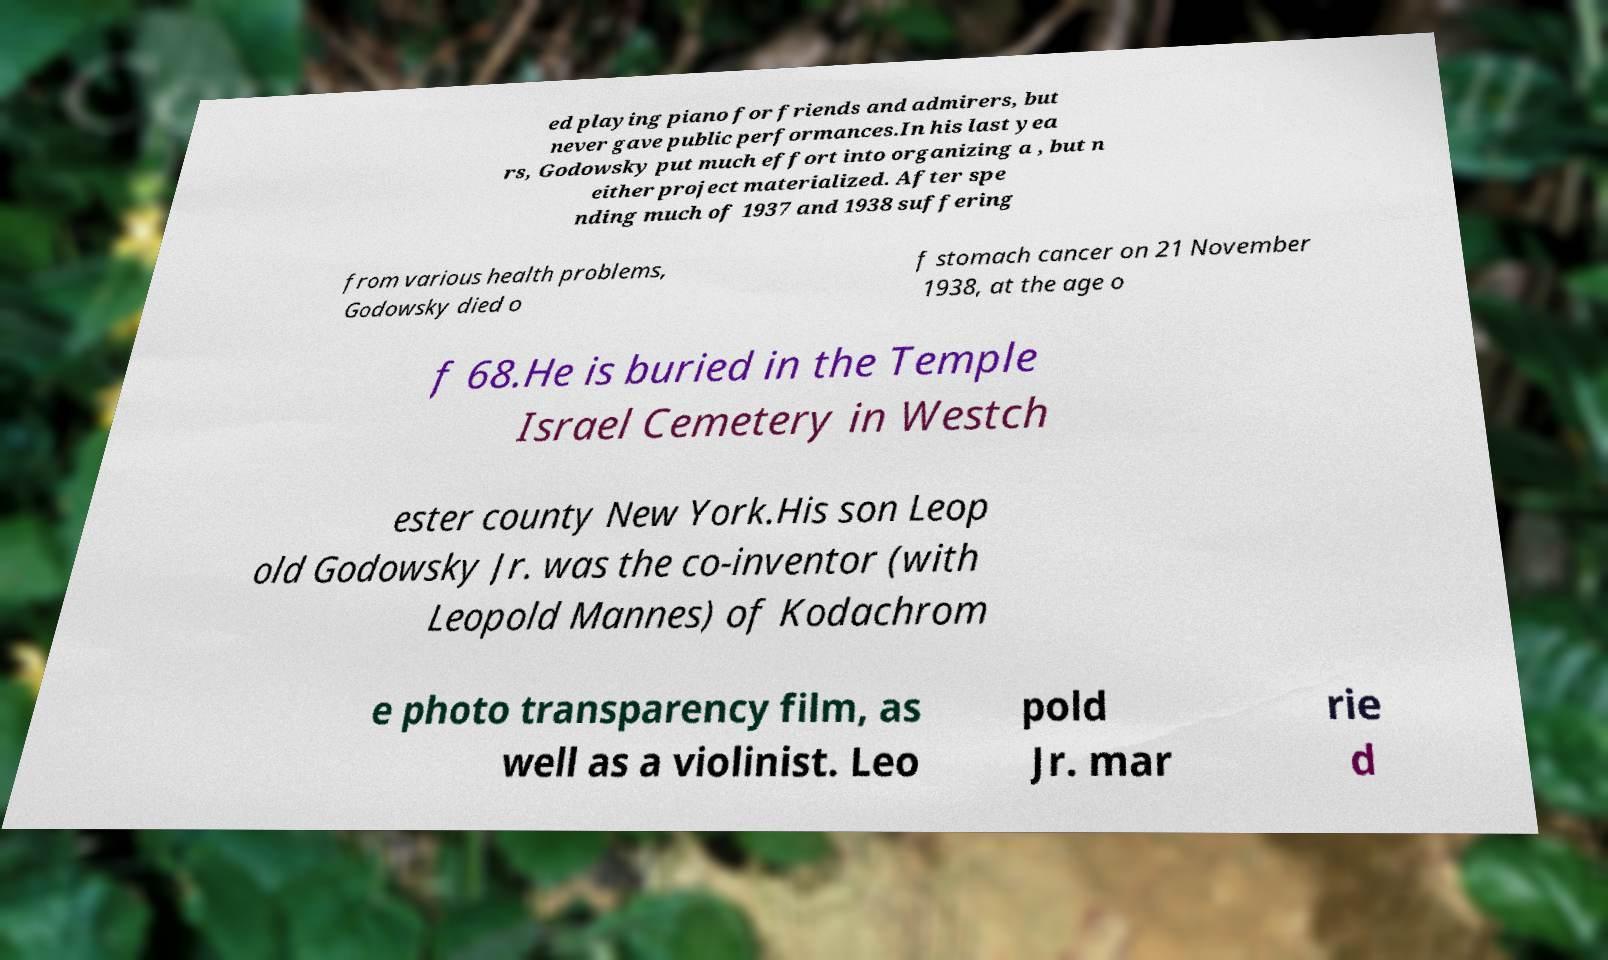I need the written content from this picture converted into text. Can you do that? ed playing piano for friends and admirers, but never gave public performances.In his last yea rs, Godowsky put much effort into organizing a , but n either project materialized. After spe nding much of 1937 and 1938 suffering from various health problems, Godowsky died o f stomach cancer on 21 November 1938, at the age o f 68.He is buried in the Temple Israel Cemetery in Westch ester county New York.His son Leop old Godowsky Jr. was the co-inventor (with Leopold Mannes) of Kodachrom e photo transparency film, as well as a violinist. Leo pold Jr. mar rie d 